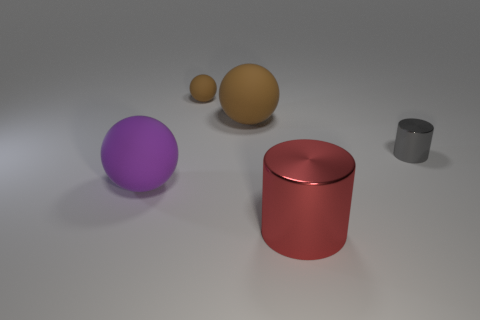What number of objects are brown rubber spheres or purple matte things left of the tiny gray metal cylinder?
Make the answer very short. 3. There is a matte object in front of the small object that is in front of the big matte sphere right of the big purple matte thing; how big is it?
Ensure brevity in your answer.  Large. What material is the object that is the same size as the gray metal cylinder?
Keep it short and to the point. Rubber. Is there a purple sphere of the same size as the purple thing?
Make the answer very short. No. There is a metallic cylinder that is behind the purple rubber sphere; does it have the same size as the large red thing?
Your response must be concise. No. There is a big thing that is both on the right side of the big purple thing and left of the red metal object; what shape is it?
Provide a succinct answer. Sphere. Is the number of big red metallic cylinders behind the gray metallic cylinder greater than the number of cylinders?
Offer a terse response. No. There is a purple object that is made of the same material as the big brown ball; what is its size?
Offer a very short reply. Large. How many big rubber things are the same color as the small metallic cylinder?
Provide a short and direct response. 0. Do the thing in front of the purple ball and the small metal cylinder have the same color?
Make the answer very short. No. 